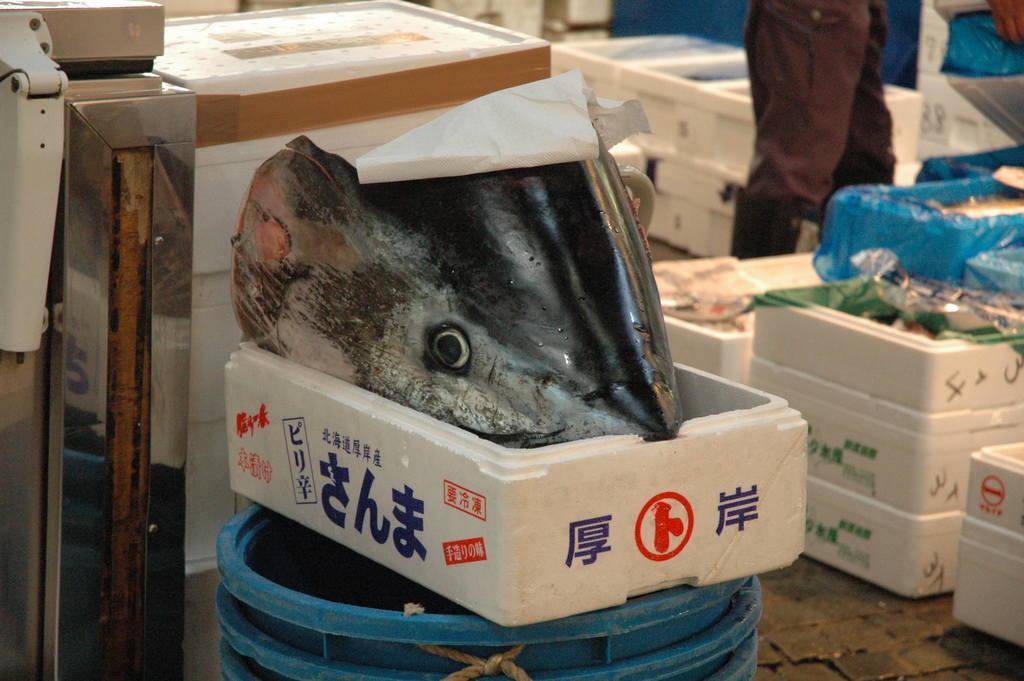Could you give a brief overview of what you see in this image? This image is taken indoors. At the bottom of the image there is a floor. In the middle of the image there is a bucket. There is a fish head in the thermocol box. In the background there are many boxes on the floor. A person is standing. On the left side of the image there is a table. 